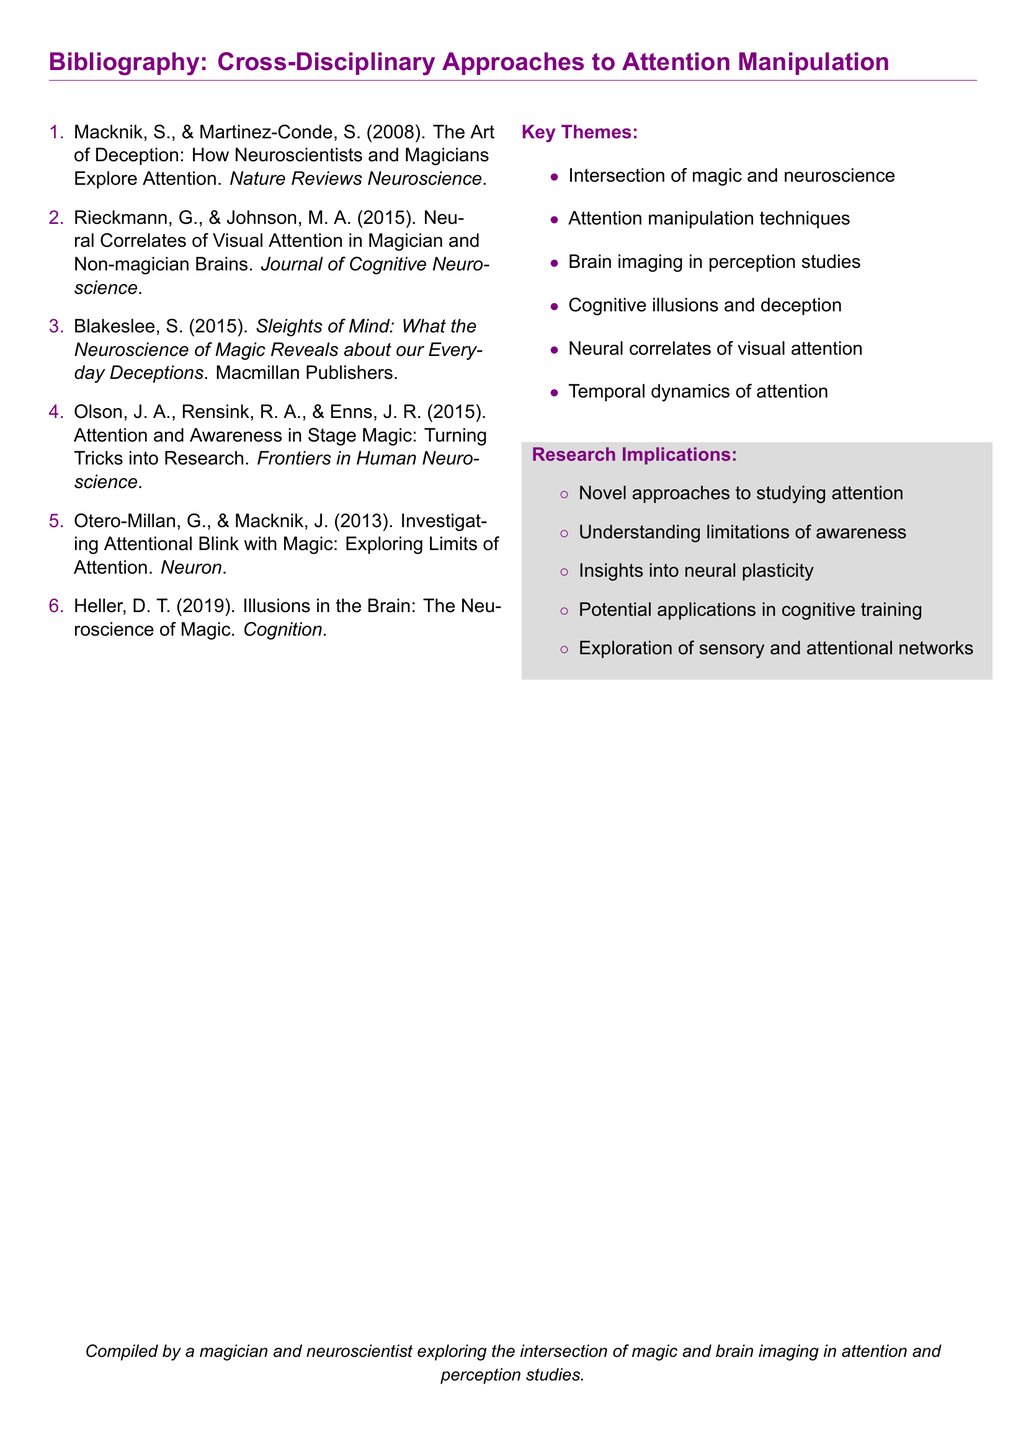What is the title of the first reference in the bibliography? The title of the first reference is found in the first item of the bibliography list.
Answer: The Art of Deception: How Neuroscientists and Magicians Explore Attention Who are the authors of the book titled "Sleights of Mind"? The authors of "Sleights of Mind" are mentioned in the third item in the bibliography.
Answer: Blakeslee, S What year was the research by Rieckmann and Johnson published? The year of publication is at the end of the entry for Rieckmann and Johnson in the bibliography.
Answer: 2015 How many key themes are listed in the document? The number of key themes can be counted from the bulleted list in the document.
Answer: Six What is one of the key themes listed? Key themes are enumerated in the bulleted section.
Answer: Intersection of magic and neuroscience Which journal published the article by Otero-Millan and Macknik? The journal name is specified in the reference for Otero-Millan and Macknik.
Answer: Neuron What does the research implication "Understanding limitations of awareness" suggest about the study? This implication points to a focus on a specific aspect of cognitive function as discussed in the document.
Answer: Insights into attentional limits Who compiled the bibliography? The document contains a note at the bottom indicating who compiled it.
Answer: A magician and neuroscientist 